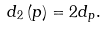<formula> <loc_0><loc_0><loc_500><loc_500>d _ { 2 } \left ( p \right ) = 2 d _ { p } .</formula> 